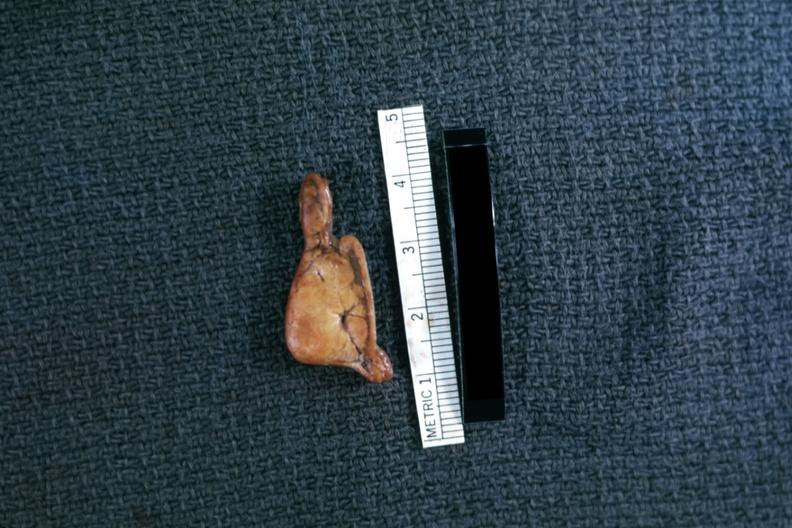s cortical nodule present?
Answer the question using a single word or phrase. Yes 